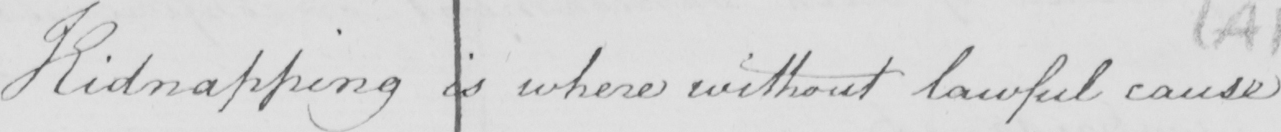Can you tell me what this handwritten text says? Kidnapping is where without lawful cause 